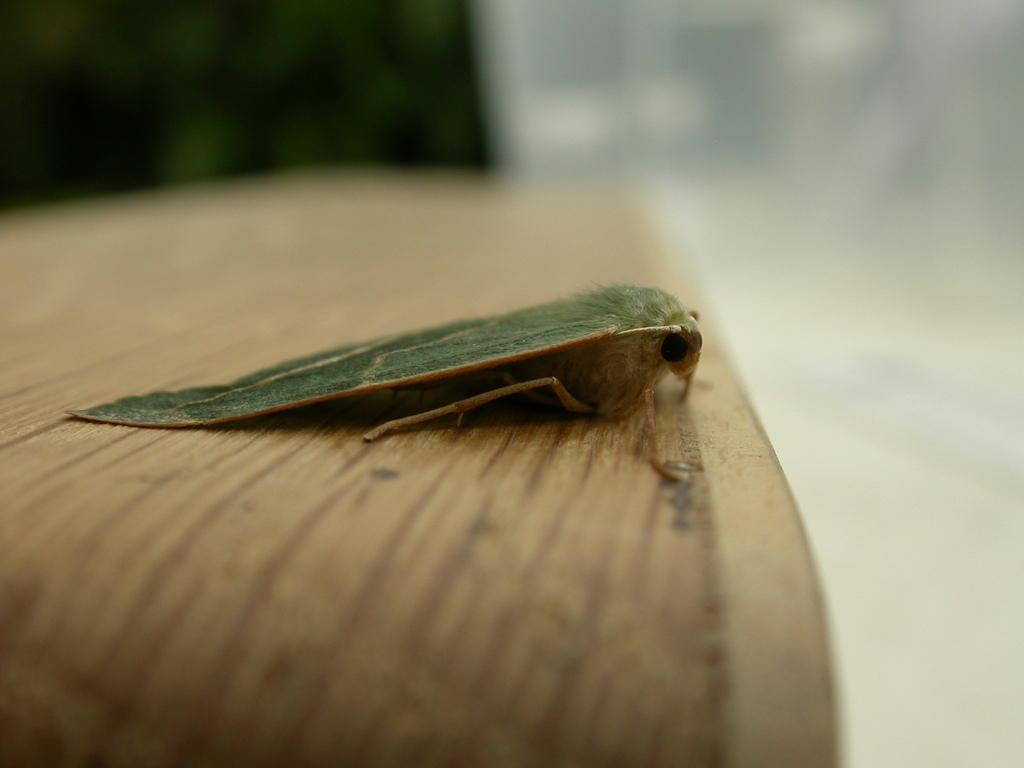What is present on the table in the image? There is an insect on the table in the image. What can be observed about the insect's appearance? The insect has green and cream colors. How would you describe the quality of the right side of the image? The right side of the image is blurry. What time does the clock on the table show in the image? There is no clock present in the image, so it is not possible to determine the time. 